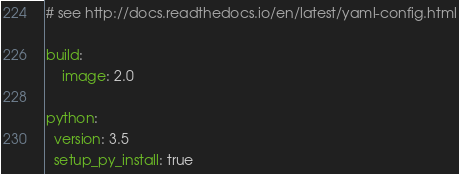<code> <loc_0><loc_0><loc_500><loc_500><_YAML_># see http://docs.readthedocs.io/en/latest/yaml-config.html

build:
    image: 2.0

python:
  version: 3.5
  setup_py_install: true</code> 